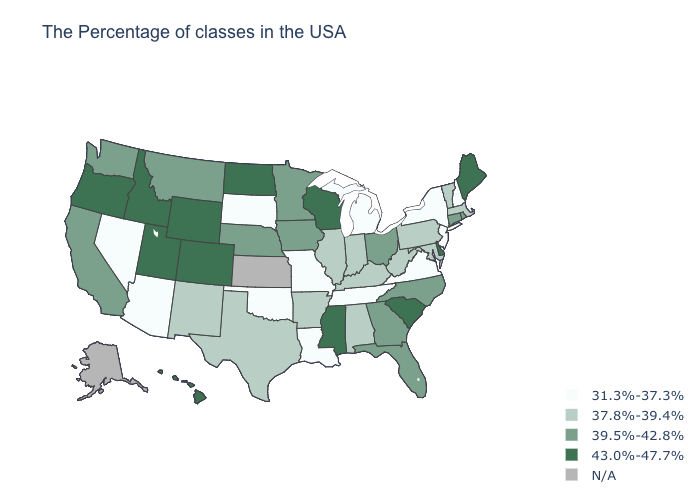Is the legend a continuous bar?
Keep it brief. No. What is the value of Massachusetts?
Be succinct. 37.8%-39.4%. Name the states that have a value in the range 43.0%-47.7%?
Quick response, please. Maine, Delaware, South Carolina, Wisconsin, Mississippi, North Dakota, Wyoming, Colorado, Utah, Idaho, Oregon, Hawaii. What is the highest value in the MidWest ?
Short answer required. 43.0%-47.7%. What is the value of Connecticut?
Keep it brief. 39.5%-42.8%. Name the states that have a value in the range 43.0%-47.7%?
Quick response, please. Maine, Delaware, South Carolina, Wisconsin, Mississippi, North Dakota, Wyoming, Colorado, Utah, Idaho, Oregon, Hawaii. What is the value of Oklahoma?
Keep it brief. 31.3%-37.3%. Does the map have missing data?
Answer briefly. Yes. What is the value of Vermont?
Give a very brief answer. 37.8%-39.4%. Among the states that border Minnesota , does North Dakota have the highest value?
Concise answer only. Yes. Which states hav the highest value in the West?
Write a very short answer. Wyoming, Colorado, Utah, Idaho, Oregon, Hawaii. What is the value of Wisconsin?
Be succinct. 43.0%-47.7%. What is the value of South Dakota?
Keep it brief. 31.3%-37.3%. 